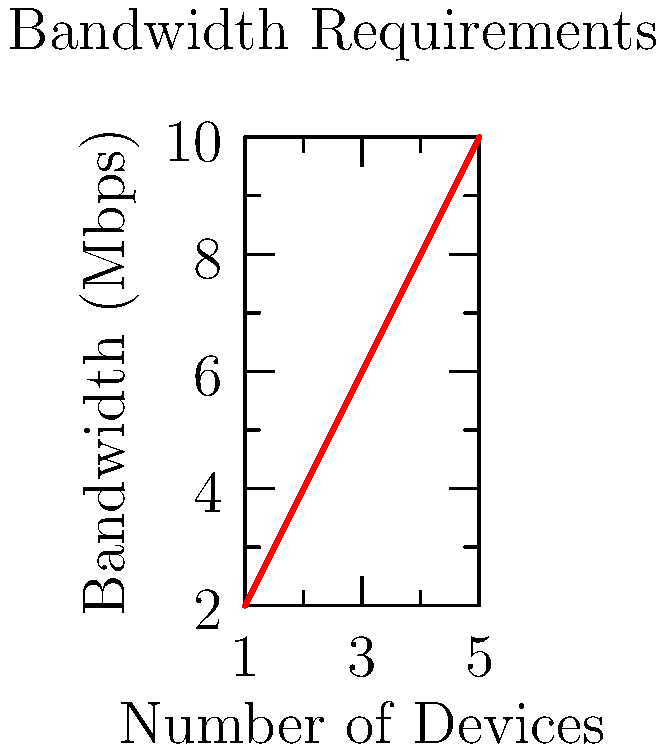Your aunt wants to stream high-quality beauty tutorials on multiple devices in the salon. The graph shows the relationship between the number of devices and the required bandwidth. If each device requires an additional 2 Mbps of bandwidth, what is the total bandwidth needed for 7 devices? To solve this problem, we need to follow these steps:

1. Understand the relationship:
   The graph shows that for each additional device, 2 Mbps of bandwidth is required.

2. Determine the linear equation:
   The relationship can be expressed as $y = 2x$, where:
   $y$ = total bandwidth required (in Mbps)
   $x$ = number of devices

3. Calculate the bandwidth for 7 devices:
   $y = 2x$
   $y = 2 \times 7$
   $y = 14$

Therefore, the total bandwidth required for 7 devices is 14 Mbps.
Answer: 14 Mbps 